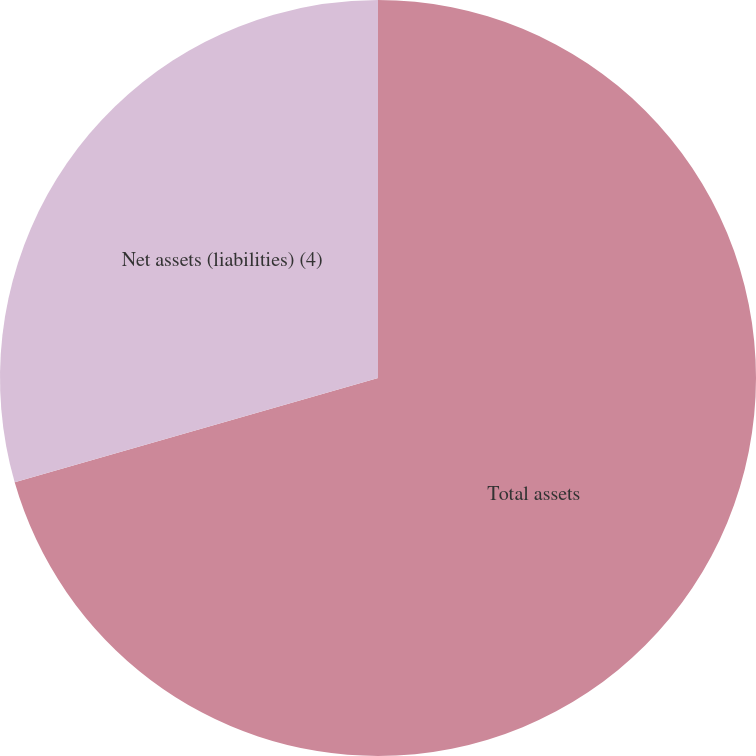Convert chart to OTSL. <chart><loc_0><loc_0><loc_500><loc_500><pie_chart><fcel>Total assets<fcel>Net assets (liabilities) (4)<nl><fcel>70.55%<fcel>29.45%<nl></chart> 